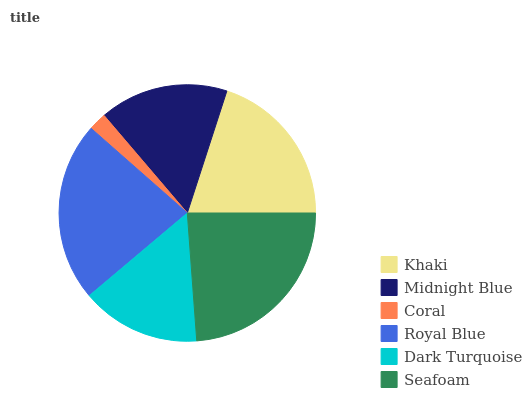Is Coral the minimum?
Answer yes or no. Yes. Is Seafoam the maximum?
Answer yes or no. Yes. Is Midnight Blue the minimum?
Answer yes or no. No. Is Midnight Blue the maximum?
Answer yes or no. No. Is Khaki greater than Midnight Blue?
Answer yes or no. Yes. Is Midnight Blue less than Khaki?
Answer yes or no. Yes. Is Midnight Blue greater than Khaki?
Answer yes or no. No. Is Khaki less than Midnight Blue?
Answer yes or no. No. Is Khaki the high median?
Answer yes or no. Yes. Is Midnight Blue the low median?
Answer yes or no. Yes. Is Royal Blue the high median?
Answer yes or no. No. Is Coral the low median?
Answer yes or no. No. 